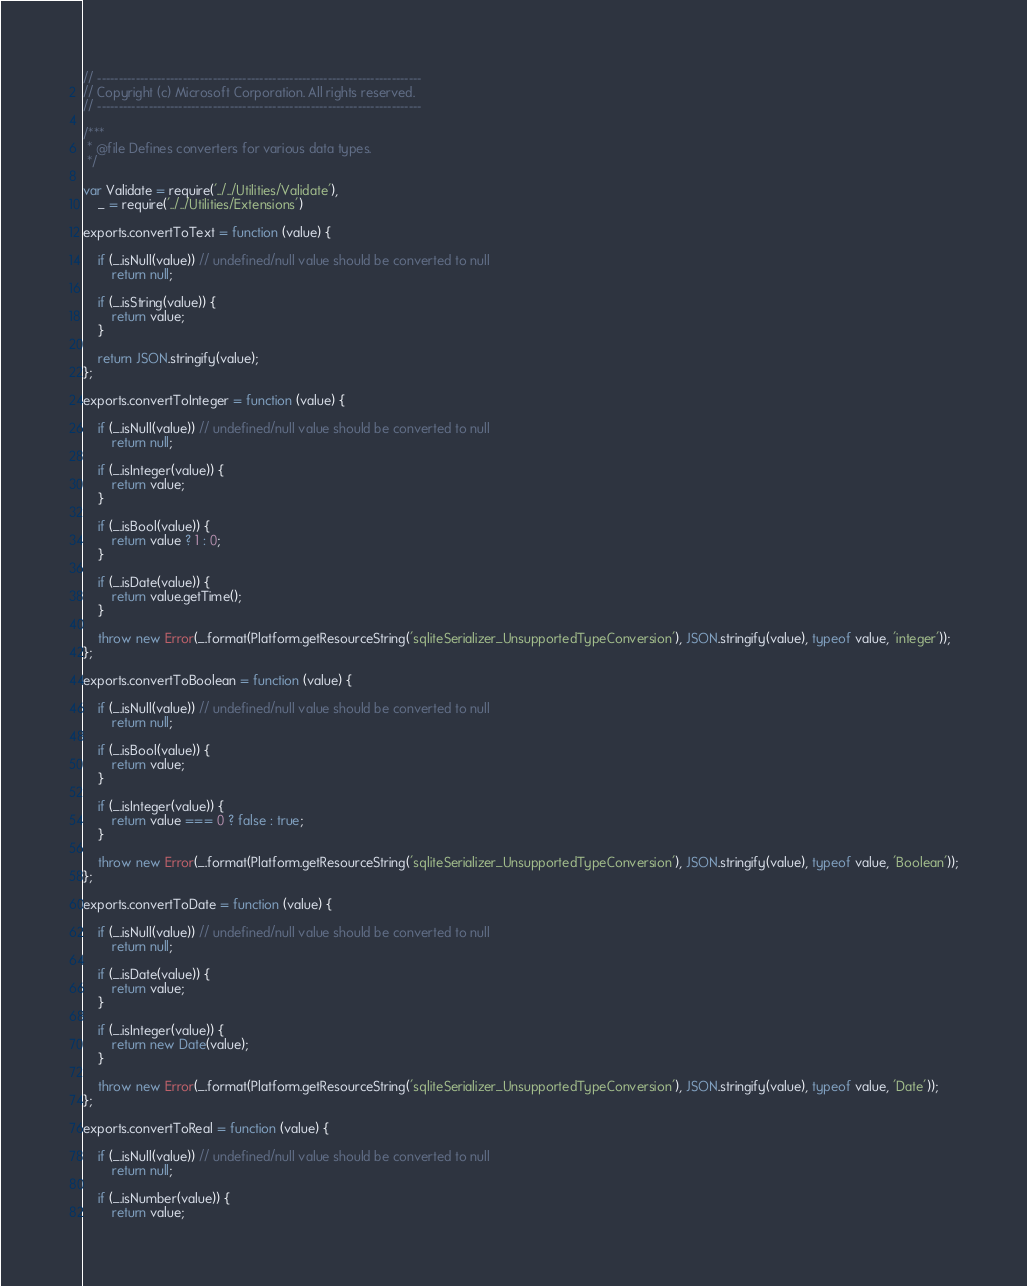Convert code to text. <code><loc_0><loc_0><loc_500><loc_500><_JavaScript_>// ----------------------------------------------------------------------------
// Copyright (c) Microsoft Corporation. All rights reserved.
// ----------------------------------------------------------------------------

/***
 * @file Defines converters for various data types.
 */

var Validate = require('../../Utilities/Validate'),
    _ = require('../../Utilities/Extensions')

exports.convertToText = function (value) {
    
    if (_.isNull(value)) // undefined/null value should be converted to null
        return null;

    if (_.isString(value)) {
        return value;
    }

    return JSON.stringify(value);
};

exports.convertToInteger = function (value) {

    if (_.isNull(value)) // undefined/null value should be converted to null
        return null;

    if (_.isInteger(value)) {
        return value;
    }

    if (_.isBool(value)) {
        return value ? 1 : 0;
    }
    
    if (_.isDate(value)) {
        return value.getTime();
    }

    throw new Error(_.format(Platform.getResourceString('sqliteSerializer_UnsupportedTypeConversion'), JSON.stringify(value), typeof value, 'integer'));
};

exports.convertToBoolean = function (value) {

    if (_.isNull(value)) // undefined/null value should be converted to null
        return null;

    if (_.isBool(value)) {
        return value;
    }

    if (_.isInteger(value)) {
        return value === 0 ? false : true;
    }
        
    throw new Error(_.format(Platform.getResourceString('sqliteSerializer_UnsupportedTypeConversion'), JSON.stringify(value), typeof value, 'Boolean'));
};

exports.convertToDate = function (value) {

    if (_.isNull(value)) // undefined/null value should be converted to null
        return null;

    if (_.isDate(value)) {
        return value;
    }

    if (_.isInteger(value)) {
        return new Date(value);
    } 

    throw new Error(_.format(Platform.getResourceString('sqliteSerializer_UnsupportedTypeConversion'), JSON.stringify(value), typeof value, 'Date'));
};

exports.convertToReal = function (value) {

    if (_.isNull(value)) // undefined/null value should be converted to null
        return null;

    if (_.isNumber(value)) {
        return value;</code> 